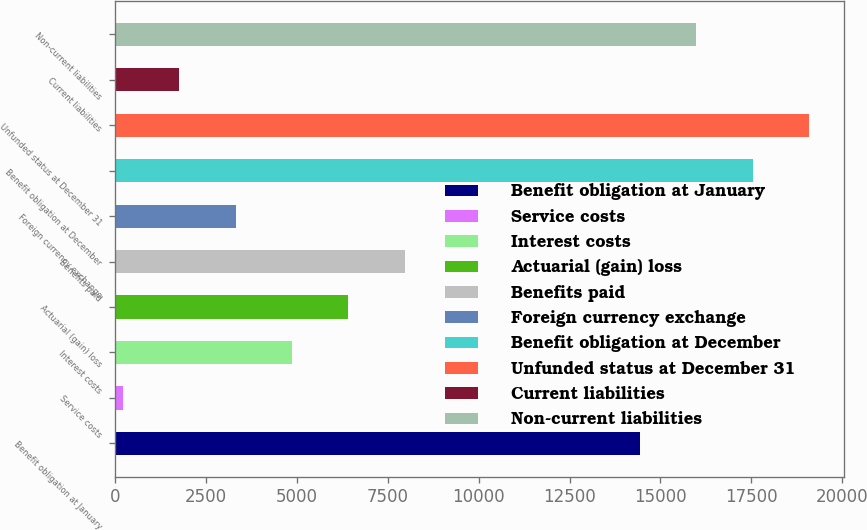Convert chart. <chart><loc_0><loc_0><loc_500><loc_500><bar_chart><fcel>Benefit obligation at January<fcel>Service costs<fcel>Interest costs<fcel>Actuarial (gain) loss<fcel>Benefits paid<fcel>Foreign currency exchange<fcel>Benefit obligation at December<fcel>Unfunded status at December 31<fcel>Current liabilities<fcel>Non-current liabilities<nl><fcel>14437<fcel>221<fcel>4870.1<fcel>6419.8<fcel>7969.5<fcel>3320.4<fcel>17536.4<fcel>19086.1<fcel>1770.7<fcel>15986.7<nl></chart> 